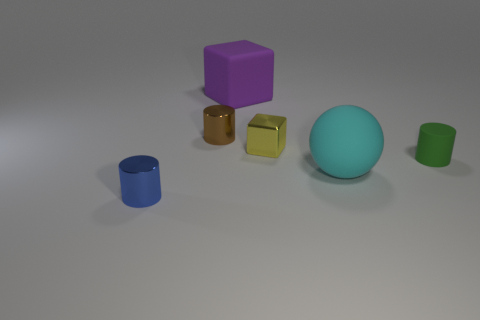Add 4 blue shiny cylinders. How many objects exist? 10 Subtract all spheres. How many objects are left? 5 Add 5 tiny blocks. How many tiny blocks exist? 6 Subtract 0 red cubes. How many objects are left? 6 Subtract all large red balls. Subtract all shiny cylinders. How many objects are left? 4 Add 2 large purple rubber blocks. How many large purple rubber blocks are left? 3 